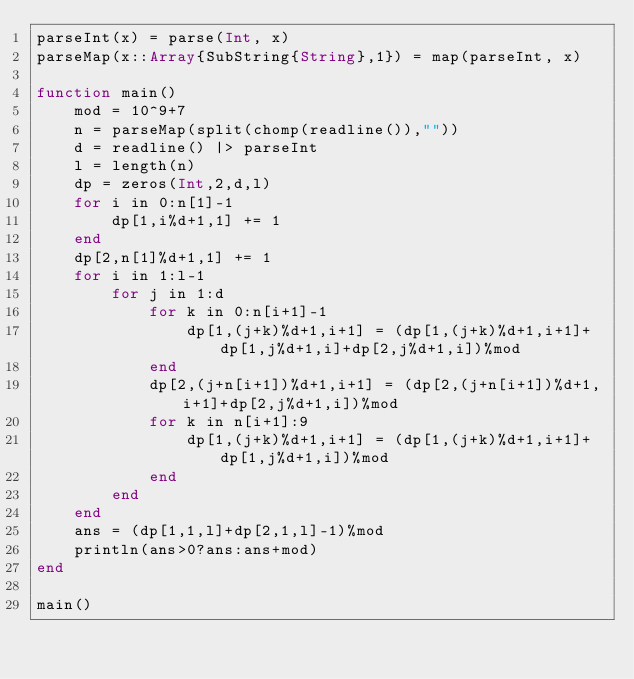<code> <loc_0><loc_0><loc_500><loc_500><_Julia_>parseInt(x) = parse(Int, x)
parseMap(x::Array{SubString{String},1}) = map(parseInt, x)

function main()
	mod = 10^9+7
	n = parseMap(split(chomp(readline()),""))
	d = readline() |> parseInt
	l = length(n)
	dp = zeros(Int,2,d,l)
	for i in 0:n[1]-1
		dp[1,i%d+1,1] += 1
	end
	dp[2,n[1]%d+1,1] += 1
	for i in 1:l-1
		for j in 1:d
			for k in 0:n[i+1]-1
				dp[1,(j+k)%d+1,i+1] = (dp[1,(j+k)%d+1,i+1]+dp[1,j%d+1,i]+dp[2,j%d+1,i])%mod
			end
			dp[2,(j+n[i+1])%d+1,i+1] = (dp[2,(j+n[i+1])%d+1,i+1]+dp[2,j%d+1,i])%mod
			for k in n[i+1]:9
				dp[1,(j+k)%d+1,i+1] = (dp[1,(j+k)%d+1,i+1]+dp[1,j%d+1,i])%mod
			end
		end
	end
	ans = (dp[1,1,l]+dp[2,1,l]-1)%mod
	println(ans>0?ans:ans+mod)
end

main()</code> 